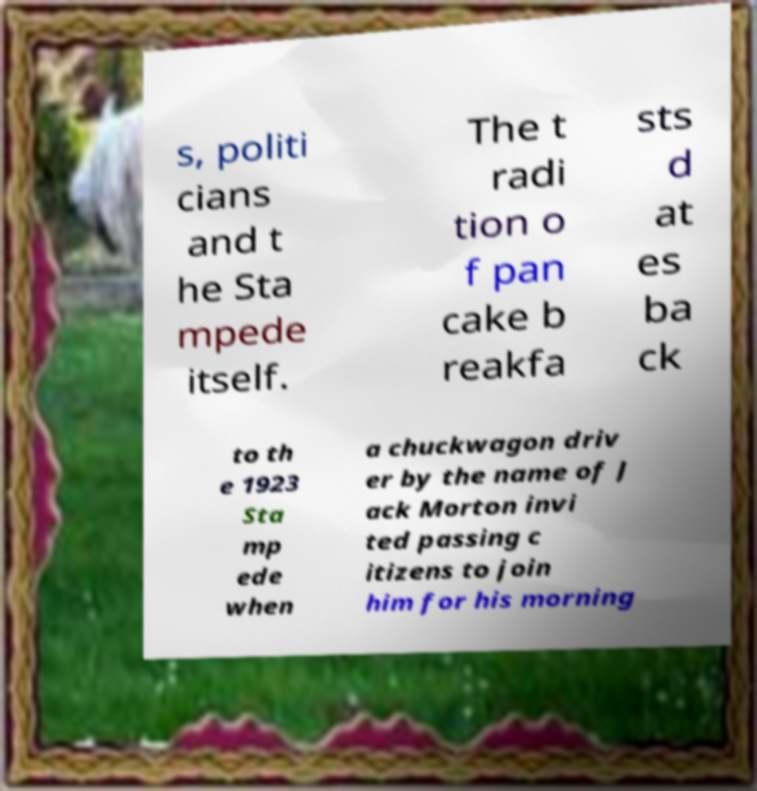Can you read and provide the text displayed in the image?This photo seems to have some interesting text. Can you extract and type it out for me? s, politi cians and t he Sta mpede itself. The t radi tion o f pan cake b reakfa sts d at es ba ck to th e 1923 Sta mp ede when a chuckwagon driv er by the name of J ack Morton invi ted passing c itizens to join him for his morning 